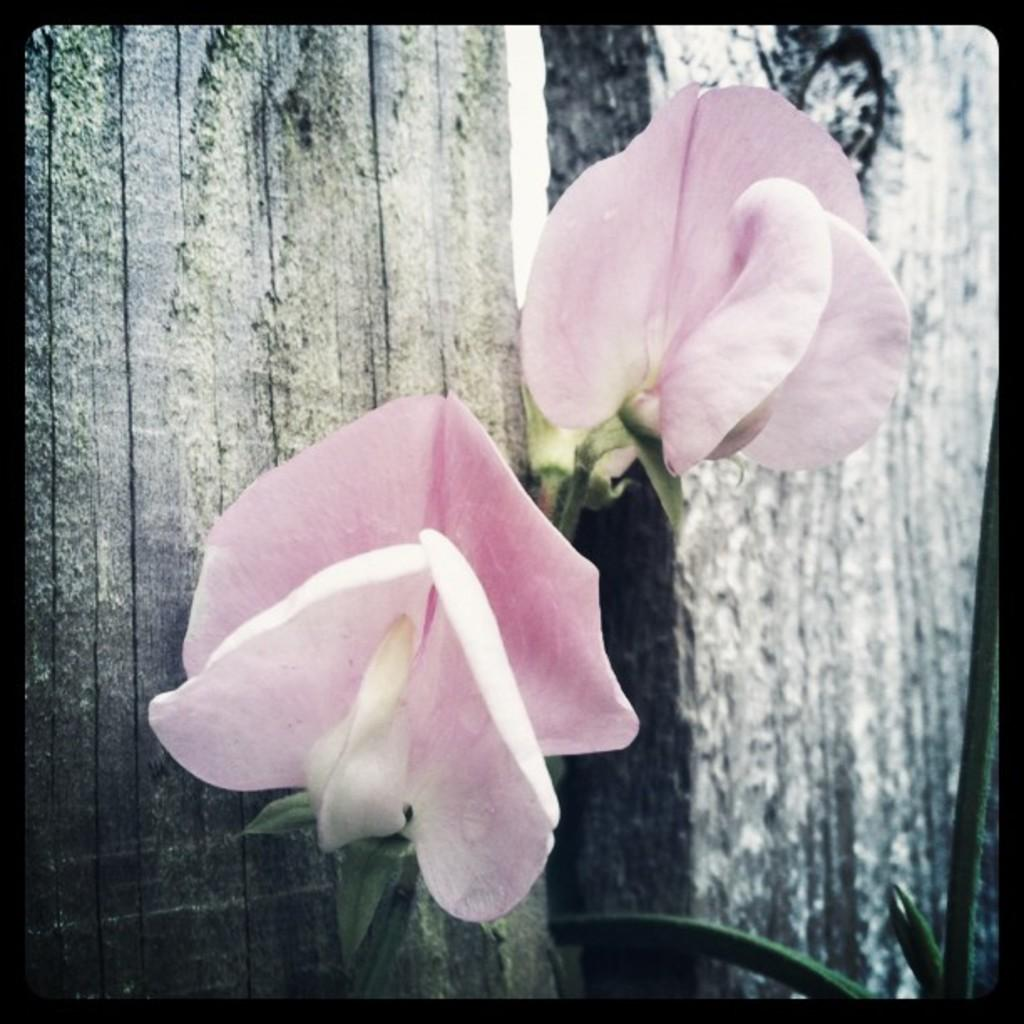How many flowers are present in the image? There are 2 flowers in the image. What color are the flowers? The flowers are pink in color. Can you describe the green element in the image? There is a green color thing in the image. How many babies are crawling around the flowers in the image? There are no babies present in the image; it only features flowers and a green element. 